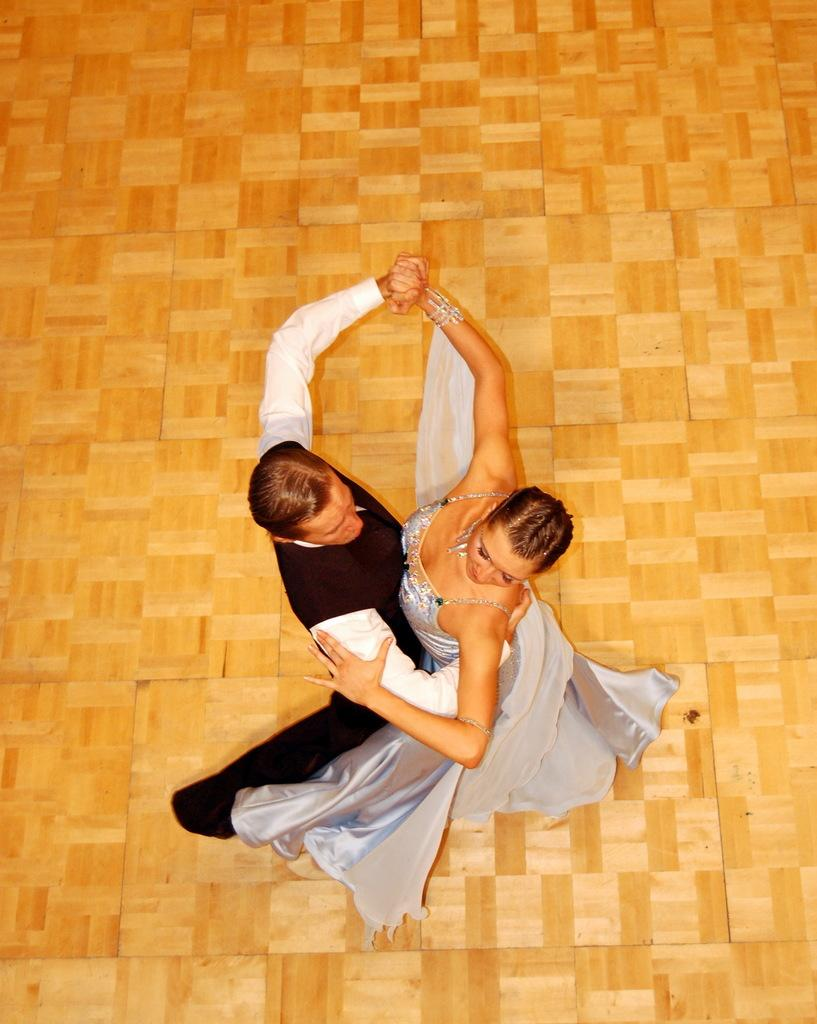Who can be seen in the image? There is a couple in the image. What are the couple doing in the image? The couple is dancing on the floor. What is the man wearing in the image? The man is wearing a black and white dress. What is the color of the floor in the image? The floor is in brown color. Where is the crate located in the image? There is no crate present in the image. What type of shoes is the brother wearing in the image? There is no brother or shoes mentioned in the image; it only features a couple dancing. 